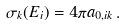Convert formula to latex. <formula><loc_0><loc_0><loc_500><loc_500>\sigma _ { k } ( E _ { i } ) = 4 { \pi } a _ { 0 , i k } \, .</formula> 